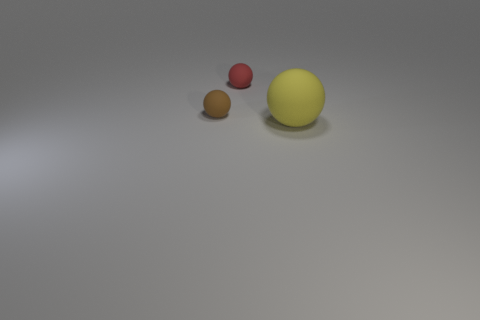Can you describe the arrangement of the balls in the image? The objects are arranged in a triangular formation with the yellow ball at the apex and the red and brown balls forming the base, with the red ball positioned slightly to the front. 